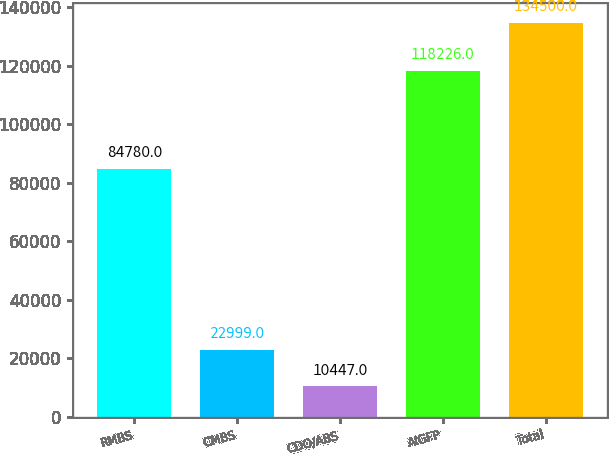Convert chart. <chart><loc_0><loc_0><loc_500><loc_500><bar_chart><fcel>RMBS<fcel>CMBS<fcel>CDO/ABS<fcel>AIGFP<fcel>Total<nl><fcel>84780<fcel>22999<fcel>10447<fcel>118226<fcel>134500<nl></chart> 